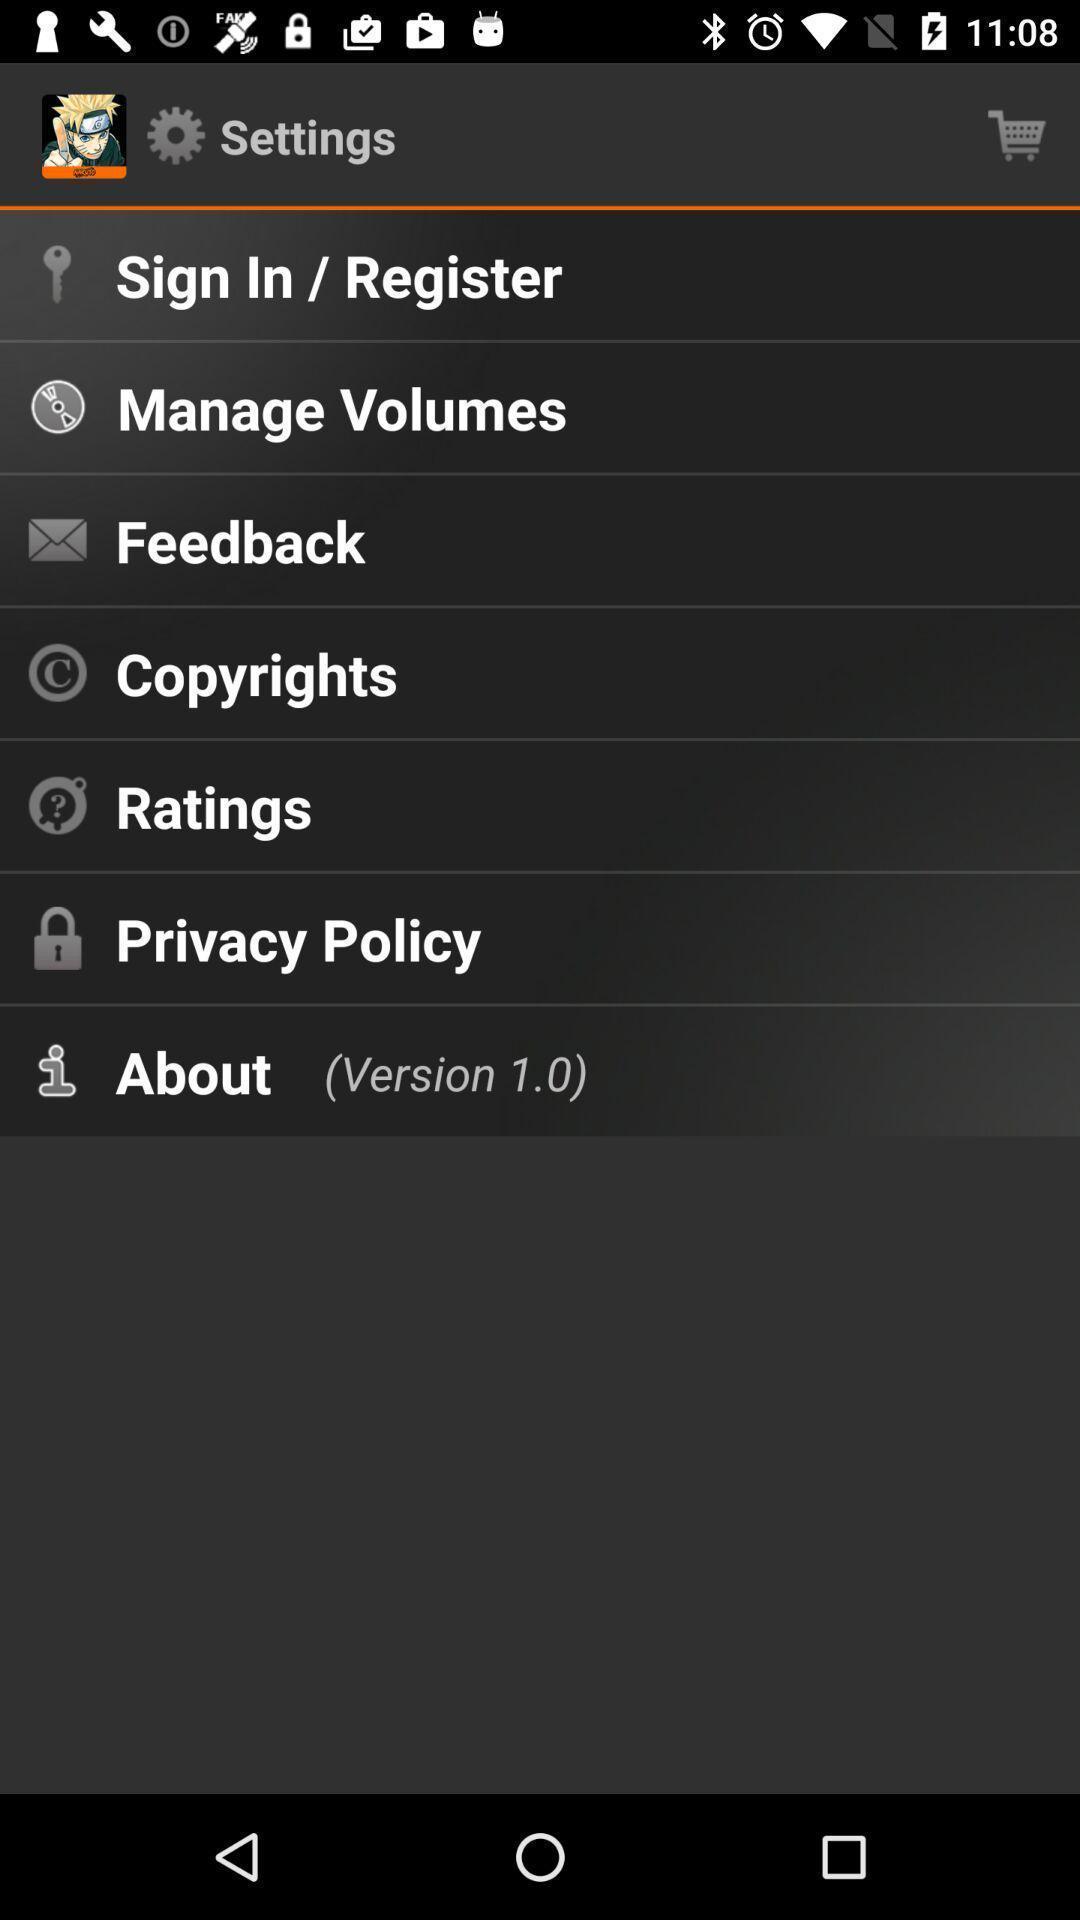Explain what's happening in this screen capture. Parameters in settings page are displaying. 